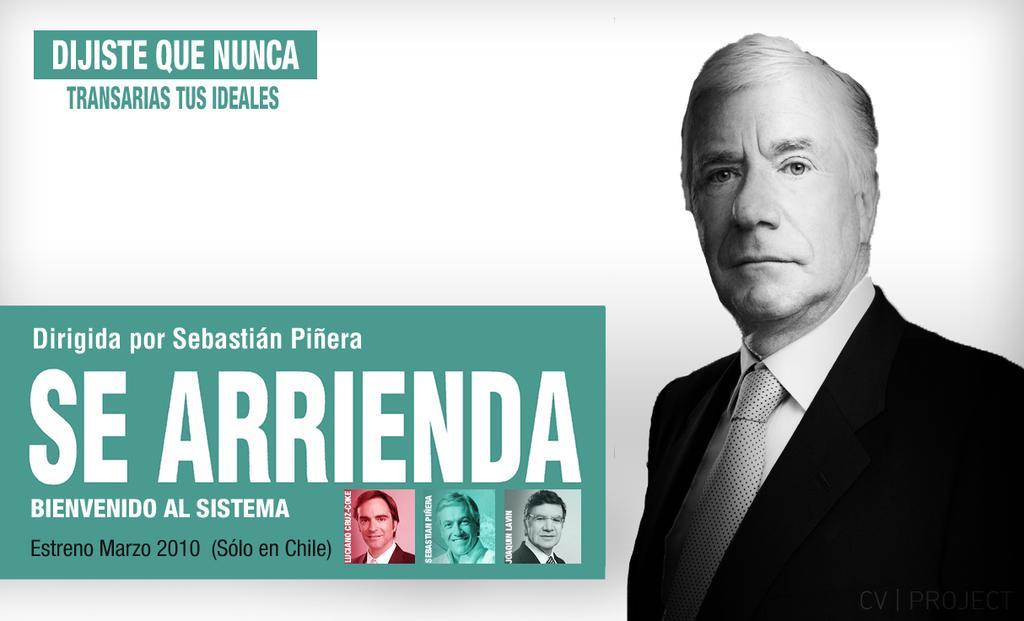Could you give a brief overview of what you see in this image? On the right side, the man in white shirt and black blazer is standing. On the left side, we see some text written on the green color chart like. We even see the photos of men. In the left top of the picture, we see some text written. In the background, it is white in color. This picture might be a poster or an edited image. 